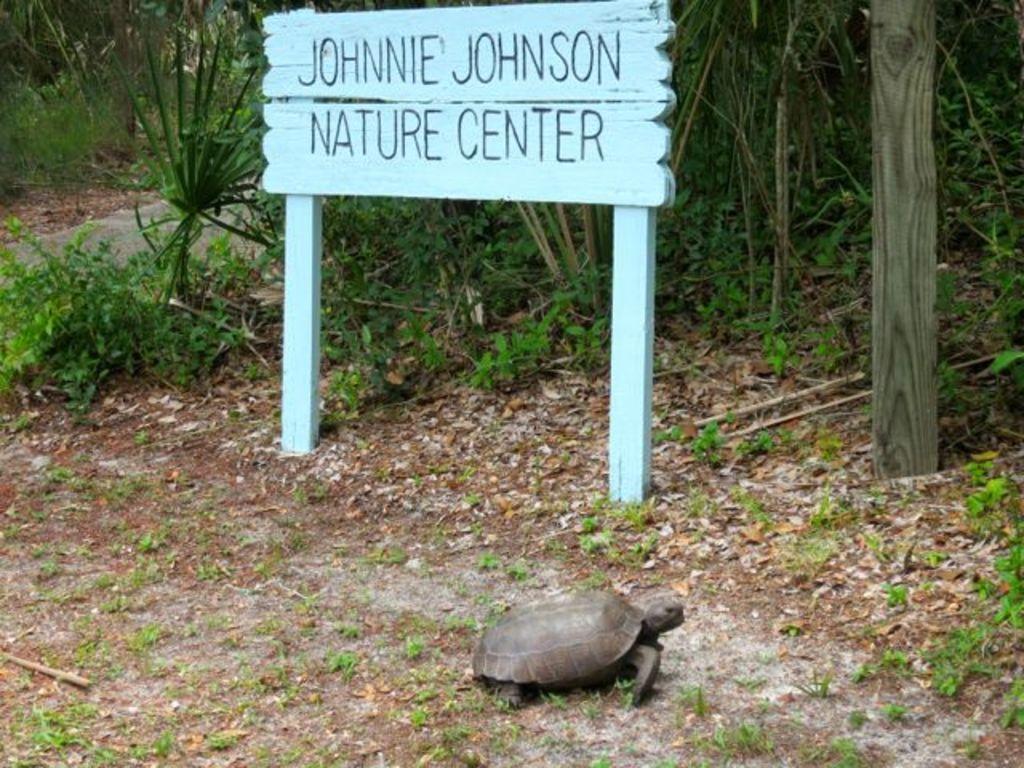Describe this image in one or two sentences. In this image, we can see a turtle on the ground and in the background, there are trees and we can see a name board and a pole. 